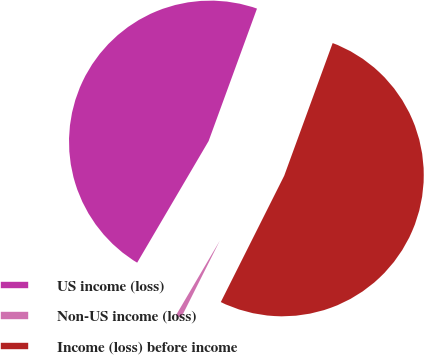Convert chart. <chart><loc_0><loc_0><loc_500><loc_500><pie_chart><fcel>US income (loss)<fcel>Non-US income (loss)<fcel>Income (loss) before income<nl><fcel>47.12%<fcel>1.05%<fcel>51.83%<nl></chart> 